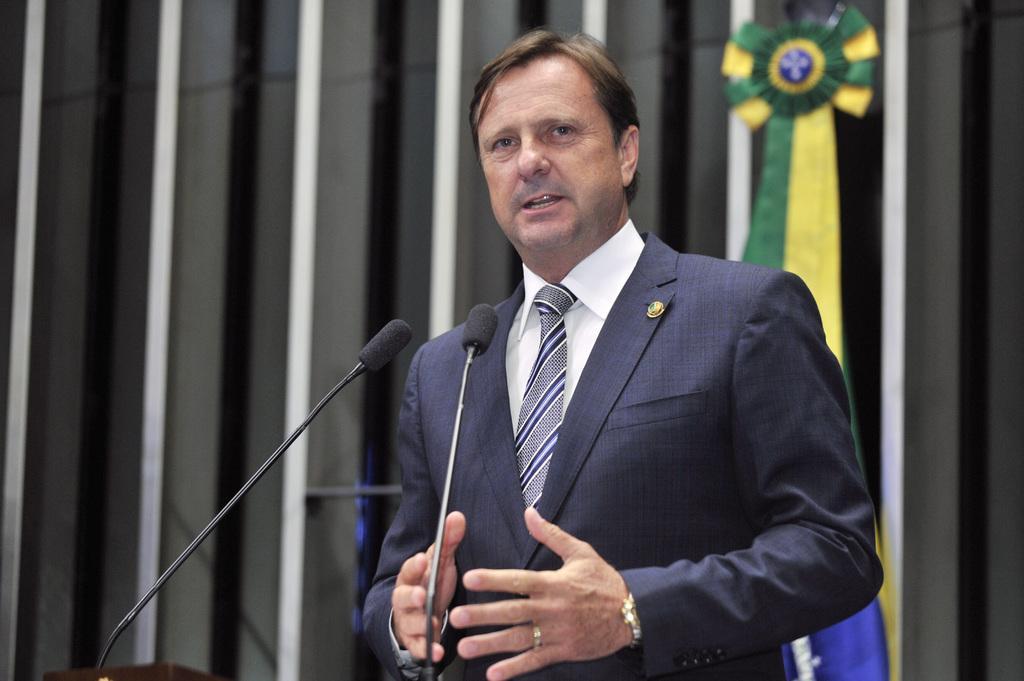Please provide a concise description of this image. In the image in the center we can see one person standing. In front of him,we can see two microphones. In the background there is a wall and one green and yellow color object. 